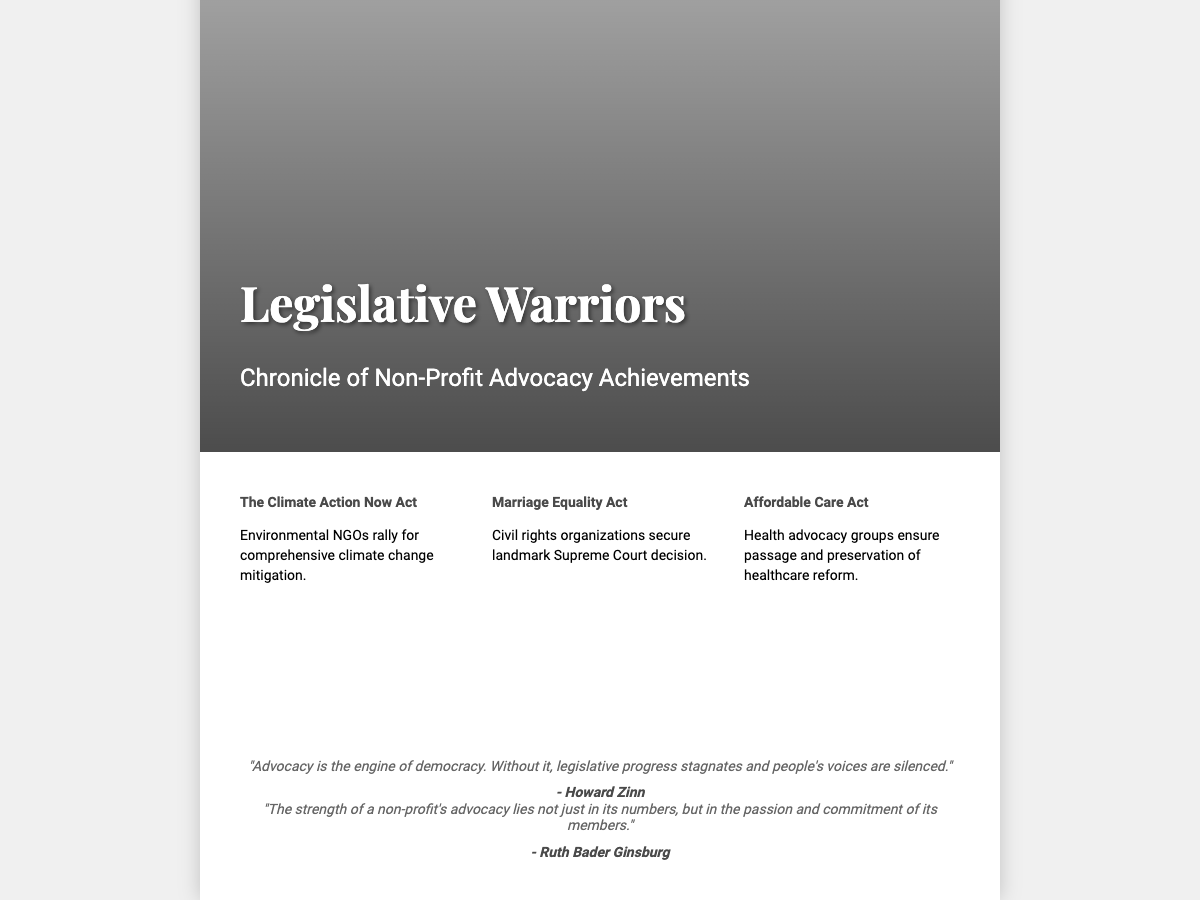What is the title of the book? The title of the book is prominently displayed on the cover.
Answer: Legislative Warriors What is the subtitle of the book? The subtitle provides additional context about the content of the book.
Answer: Chronicle of Non-Profit Advocacy Achievements What iconic elements are included in the book cover image? The image features a notable animal and buildings that symbolize legislative power.
Answer: A lion and legislative buildings Name one legislative act highlighted on the cover. The cover lists specific acts that represent achievements in advocacy.
Answer: The Climate Action Now Act Who is one of the authors of the quotes on the cover? The quotes on the cover are attributed to notable figures.
Answer: Howard Zinn What theme does the quote by Ruth Bader Ginsburg convey? The quote reflects on what underpins strong advocacy efforts.
Answer: Passion and commitment How many highlighted acts are mentioned on the cover? The cover displays a specific number of highlighted achievements.
Answer: Three What type of organization is primarily discussed in the book? The theme of the book revolves around a specific type of organization involved in advocacy.
Answer: Non-Profit Organizations What visual representation is used to convey strength on the cover? The cover uses a specific animal to symbolize strength.
Answer: Lion 